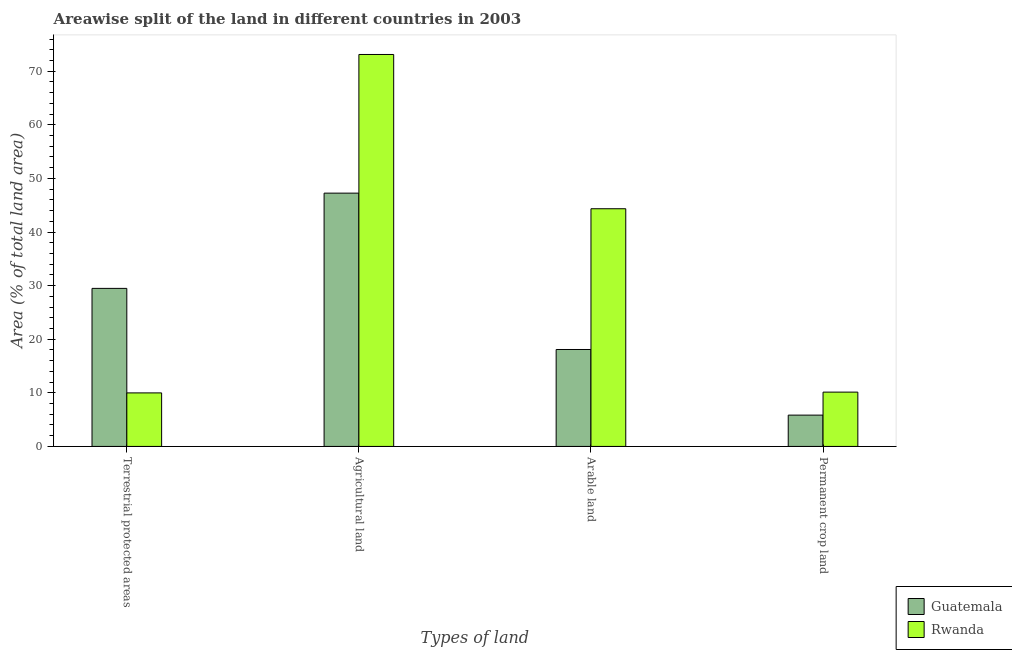Are the number of bars per tick equal to the number of legend labels?
Offer a terse response. Yes. How many bars are there on the 2nd tick from the left?
Offer a very short reply. 2. What is the label of the 1st group of bars from the left?
Give a very brief answer. Terrestrial protected areas. What is the percentage of area under permanent crop land in Rwanda?
Provide a short and direct response. 10.13. Across all countries, what is the maximum percentage of area under arable land?
Your answer should be compact. 44.35. Across all countries, what is the minimum percentage of area under arable land?
Ensure brevity in your answer.  18.09. In which country was the percentage of land under terrestrial protection maximum?
Your answer should be very brief. Guatemala. In which country was the percentage of land under terrestrial protection minimum?
Give a very brief answer. Rwanda. What is the total percentage of land under terrestrial protection in the graph?
Your answer should be very brief. 39.47. What is the difference between the percentage of area under arable land in Rwanda and that in Guatemala?
Provide a succinct answer. 26.26. What is the difference between the percentage of area under permanent crop land in Rwanda and the percentage of area under agricultural land in Guatemala?
Provide a succinct answer. -37.12. What is the average percentage of area under permanent crop land per country?
Keep it short and to the point. 7.99. What is the difference between the percentage of land under terrestrial protection and percentage of area under permanent crop land in Rwanda?
Keep it short and to the point. -0.15. In how many countries, is the percentage of area under permanent crop land greater than 46 %?
Make the answer very short. 0. What is the ratio of the percentage of area under agricultural land in Guatemala to that in Rwanda?
Ensure brevity in your answer.  0.65. What is the difference between the highest and the second highest percentage of land under terrestrial protection?
Make the answer very short. 19.5. What is the difference between the highest and the lowest percentage of area under agricultural land?
Offer a very short reply. 25.87. Is the sum of the percentage of land under terrestrial protection in Guatemala and Rwanda greater than the maximum percentage of area under permanent crop land across all countries?
Your response must be concise. Yes. Is it the case that in every country, the sum of the percentage of land under terrestrial protection and percentage of area under agricultural land is greater than the sum of percentage of area under arable land and percentage of area under permanent crop land?
Your answer should be very brief. Yes. What does the 2nd bar from the left in Permanent crop land represents?
Your response must be concise. Rwanda. What does the 2nd bar from the right in Agricultural land represents?
Keep it short and to the point. Guatemala. Is it the case that in every country, the sum of the percentage of land under terrestrial protection and percentage of area under agricultural land is greater than the percentage of area under arable land?
Your answer should be very brief. Yes. How many countries are there in the graph?
Your response must be concise. 2. Are the values on the major ticks of Y-axis written in scientific E-notation?
Give a very brief answer. No. Does the graph contain any zero values?
Your answer should be very brief. No. Does the graph contain grids?
Give a very brief answer. No. How are the legend labels stacked?
Ensure brevity in your answer.  Vertical. What is the title of the graph?
Ensure brevity in your answer.  Areawise split of the land in different countries in 2003. Does "Guam" appear as one of the legend labels in the graph?
Provide a succinct answer. No. What is the label or title of the X-axis?
Your response must be concise. Types of land. What is the label or title of the Y-axis?
Provide a succinct answer. Area (% of total land area). What is the Area (% of total land area) in Guatemala in Terrestrial protected areas?
Keep it short and to the point. 29.49. What is the Area (% of total land area) in Rwanda in Terrestrial protected areas?
Ensure brevity in your answer.  9.99. What is the Area (% of total land area) in Guatemala in Agricultural land?
Your answer should be compact. 47.26. What is the Area (% of total land area) of Rwanda in Agricultural land?
Make the answer very short. 73.13. What is the Area (% of total land area) of Guatemala in Arable land?
Provide a succinct answer. 18.09. What is the Area (% of total land area) in Rwanda in Arable land?
Your answer should be very brief. 44.35. What is the Area (% of total land area) of Guatemala in Permanent crop land?
Make the answer very short. 5.84. What is the Area (% of total land area) in Rwanda in Permanent crop land?
Your answer should be very brief. 10.13. Across all Types of land, what is the maximum Area (% of total land area) in Guatemala?
Keep it short and to the point. 47.26. Across all Types of land, what is the maximum Area (% of total land area) of Rwanda?
Make the answer very short. 73.13. Across all Types of land, what is the minimum Area (% of total land area) in Guatemala?
Offer a very short reply. 5.84. Across all Types of land, what is the minimum Area (% of total land area) of Rwanda?
Offer a very short reply. 9.99. What is the total Area (% of total land area) of Guatemala in the graph?
Give a very brief answer. 100.67. What is the total Area (% of total land area) of Rwanda in the graph?
Make the answer very short. 137.59. What is the difference between the Area (% of total land area) of Guatemala in Terrestrial protected areas and that in Agricultural land?
Provide a short and direct response. -17.77. What is the difference between the Area (% of total land area) of Rwanda in Terrestrial protected areas and that in Agricultural land?
Your answer should be very brief. -63.14. What is the difference between the Area (% of total land area) of Guatemala in Terrestrial protected areas and that in Arable land?
Your answer should be compact. 11.4. What is the difference between the Area (% of total land area) in Rwanda in Terrestrial protected areas and that in Arable land?
Keep it short and to the point. -34.36. What is the difference between the Area (% of total land area) in Guatemala in Terrestrial protected areas and that in Permanent crop land?
Offer a very short reply. 23.65. What is the difference between the Area (% of total land area) in Rwanda in Terrestrial protected areas and that in Permanent crop land?
Your answer should be compact. -0.15. What is the difference between the Area (% of total land area) of Guatemala in Agricultural land and that in Arable land?
Keep it short and to the point. 29.17. What is the difference between the Area (% of total land area) in Rwanda in Agricultural land and that in Arable land?
Your answer should be very brief. 28.78. What is the difference between the Area (% of total land area) in Guatemala in Agricultural land and that in Permanent crop land?
Give a very brief answer. 41.41. What is the difference between the Area (% of total land area) of Rwanda in Agricultural land and that in Permanent crop land?
Offer a terse response. 62.99. What is the difference between the Area (% of total land area) in Guatemala in Arable land and that in Permanent crop land?
Ensure brevity in your answer.  12.24. What is the difference between the Area (% of total land area) in Rwanda in Arable land and that in Permanent crop land?
Give a very brief answer. 34.21. What is the difference between the Area (% of total land area) of Guatemala in Terrestrial protected areas and the Area (% of total land area) of Rwanda in Agricultural land?
Keep it short and to the point. -43.64. What is the difference between the Area (% of total land area) of Guatemala in Terrestrial protected areas and the Area (% of total land area) of Rwanda in Arable land?
Ensure brevity in your answer.  -14.86. What is the difference between the Area (% of total land area) of Guatemala in Terrestrial protected areas and the Area (% of total land area) of Rwanda in Permanent crop land?
Keep it short and to the point. 19.35. What is the difference between the Area (% of total land area) of Guatemala in Agricultural land and the Area (% of total land area) of Rwanda in Arable land?
Offer a terse response. 2.91. What is the difference between the Area (% of total land area) in Guatemala in Agricultural land and the Area (% of total land area) in Rwanda in Permanent crop land?
Offer a terse response. 37.12. What is the difference between the Area (% of total land area) of Guatemala in Arable land and the Area (% of total land area) of Rwanda in Permanent crop land?
Provide a short and direct response. 7.95. What is the average Area (% of total land area) of Guatemala per Types of land?
Your response must be concise. 25.17. What is the average Area (% of total land area) of Rwanda per Types of land?
Your answer should be very brief. 34.4. What is the difference between the Area (% of total land area) of Guatemala and Area (% of total land area) of Rwanda in Terrestrial protected areas?
Give a very brief answer. 19.5. What is the difference between the Area (% of total land area) of Guatemala and Area (% of total land area) of Rwanda in Agricultural land?
Keep it short and to the point. -25.87. What is the difference between the Area (% of total land area) of Guatemala and Area (% of total land area) of Rwanda in Arable land?
Provide a succinct answer. -26.26. What is the difference between the Area (% of total land area) of Guatemala and Area (% of total land area) of Rwanda in Permanent crop land?
Your response must be concise. -4.29. What is the ratio of the Area (% of total land area) of Guatemala in Terrestrial protected areas to that in Agricultural land?
Keep it short and to the point. 0.62. What is the ratio of the Area (% of total land area) in Rwanda in Terrestrial protected areas to that in Agricultural land?
Give a very brief answer. 0.14. What is the ratio of the Area (% of total land area) of Guatemala in Terrestrial protected areas to that in Arable land?
Offer a very short reply. 1.63. What is the ratio of the Area (% of total land area) in Rwanda in Terrestrial protected areas to that in Arable land?
Your answer should be very brief. 0.23. What is the ratio of the Area (% of total land area) of Guatemala in Terrestrial protected areas to that in Permanent crop land?
Your response must be concise. 5.05. What is the ratio of the Area (% of total land area) in Rwanda in Terrestrial protected areas to that in Permanent crop land?
Make the answer very short. 0.99. What is the ratio of the Area (% of total land area) of Guatemala in Agricultural land to that in Arable land?
Provide a short and direct response. 2.61. What is the ratio of the Area (% of total land area) of Rwanda in Agricultural land to that in Arable land?
Give a very brief answer. 1.65. What is the ratio of the Area (% of total land area) in Guatemala in Agricultural land to that in Permanent crop land?
Make the answer very short. 8.09. What is the ratio of the Area (% of total land area) of Rwanda in Agricultural land to that in Permanent crop land?
Ensure brevity in your answer.  7.22. What is the ratio of the Area (% of total land area) of Guatemala in Arable land to that in Permanent crop land?
Your response must be concise. 3.1. What is the ratio of the Area (% of total land area) in Rwanda in Arable land to that in Permanent crop land?
Offer a terse response. 4.38. What is the difference between the highest and the second highest Area (% of total land area) of Guatemala?
Make the answer very short. 17.77. What is the difference between the highest and the second highest Area (% of total land area) of Rwanda?
Provide a succinct answer. 28.78. What is the difference between the highest and the lowest Area (% of total land area) in Guatemala?
Your response must be concise. 41.41. What is the difference between the highest and the lowest Area (% of total land area) of Rwanda?
Offer a terse response. 63.14. 